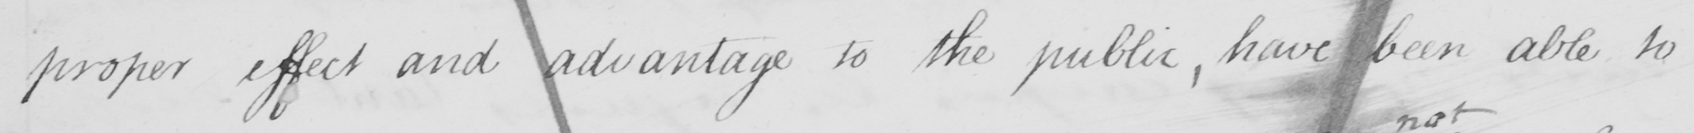What text is written in this handwritten line? proper effect and advantage to the public, have been able to 